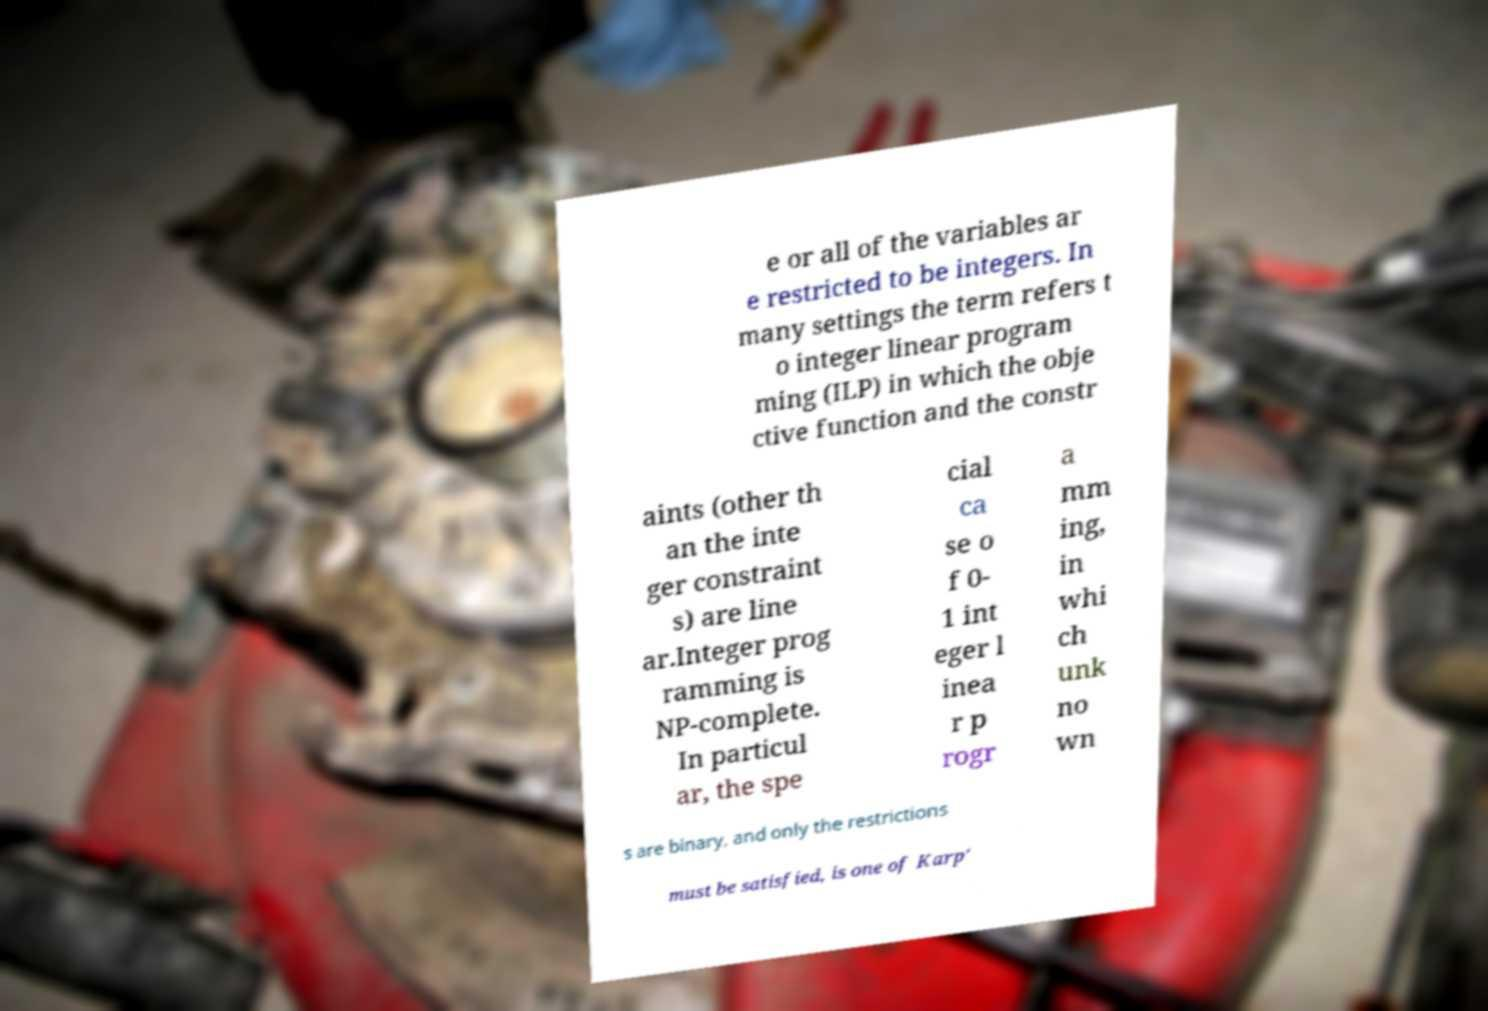Please identify and transcribe the text found in this image. e or all of the variables ar e restricted to be integers. In many settings the term refers t o integer linear program ming (ILP) in which the obje ctive function and the constr aints (other th an the inte ger constraint s) are line ar.Integer prog ramming is NP-complete. In particul ar, the spe cial ca se o f 0- 1 int eger l inea r p rogr a mm ing, in whi ch unk no wn s are binary, and only the restrictions must be satisfied, is one of Karp' 